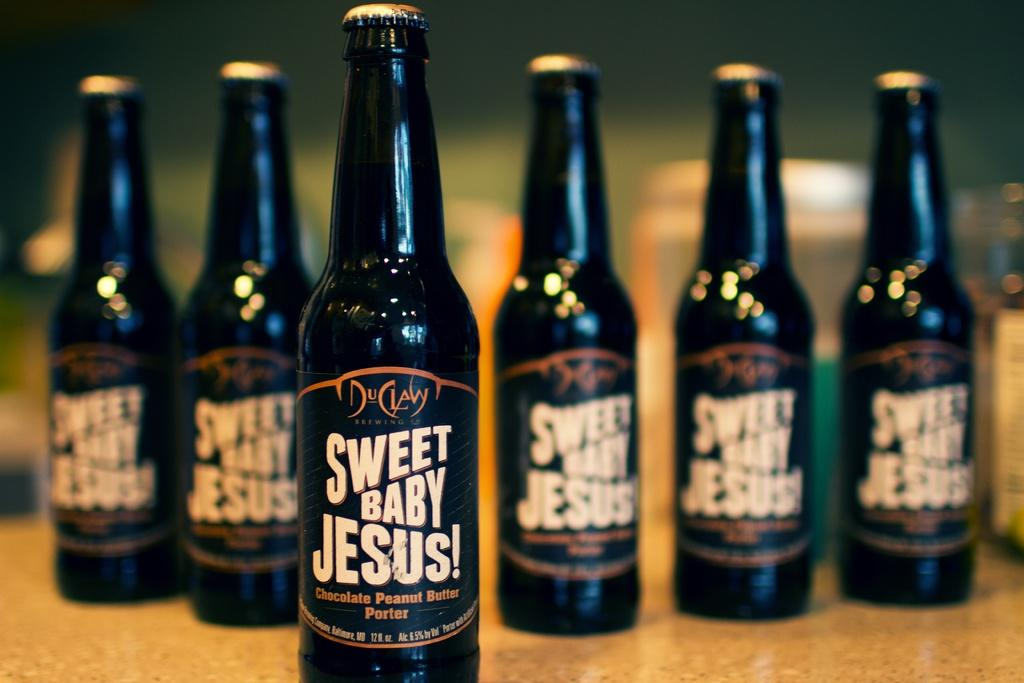What is located in the foreground of the picture? There is a bottle in the foreground of the picture. How would you describe the background of the image? The background of the image is blurred. Can you see any other bottles in the image? Yes, there are bottles visible in the background of the image. What type of note can be seen hanging from the bottle in the image? There is no note hanging from the bottle in the image. 